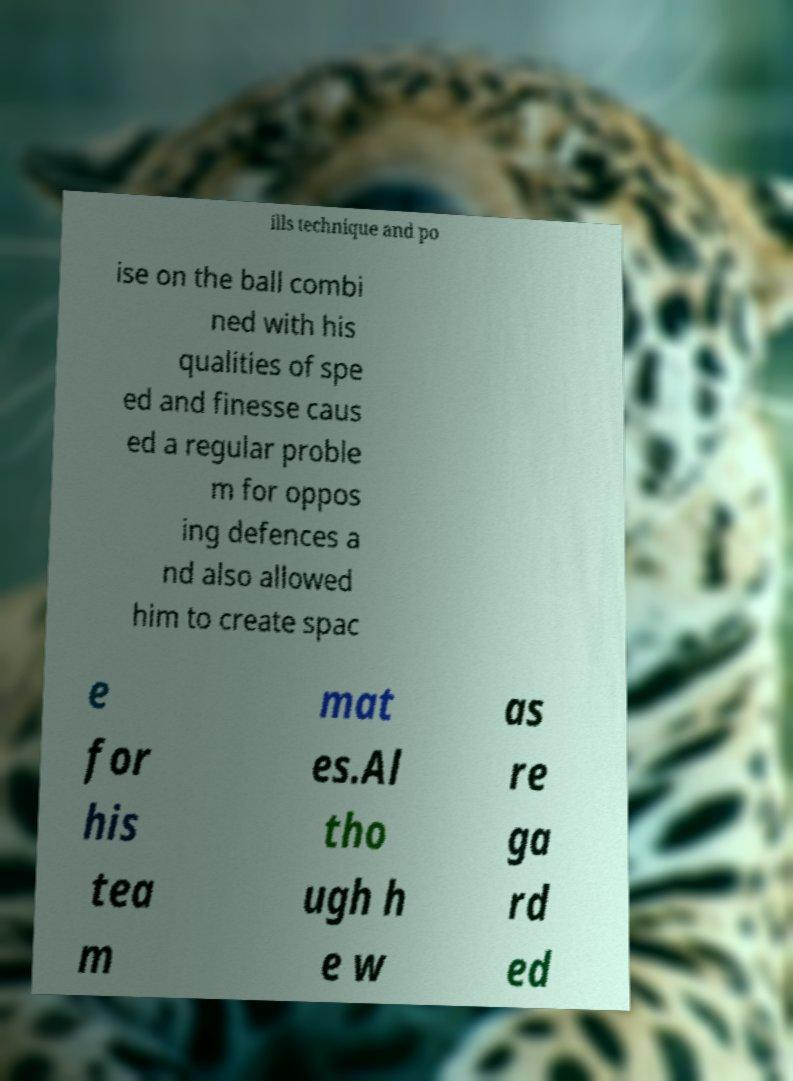What messages or text are displayed in this image? I need them in a readable, typed format. ills technique and po ise on the ball combi ned with his qualities of spe ed and finesse caus ed a regular proble m for oppos ing defences a nd also allowed him to create spac e for his tea m mat es.Al tho ugh h e w as re ga rd ed 